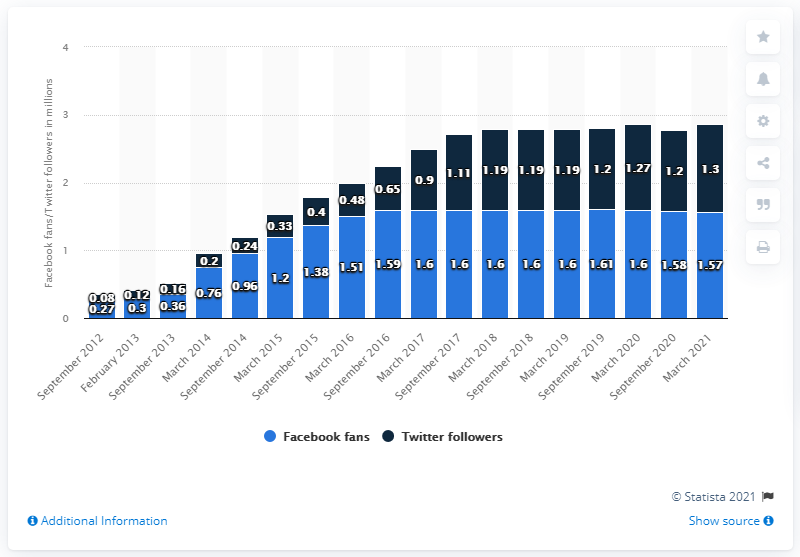Outline some significant characteristics in this image. In 2012, the year had the least number of followers. The ratio of Facebook fans between the years 2017 and 2018 was 1. In March 2021, the number of people who were following the Facebook page of the Atlanta Hawks was 1.57 million. 